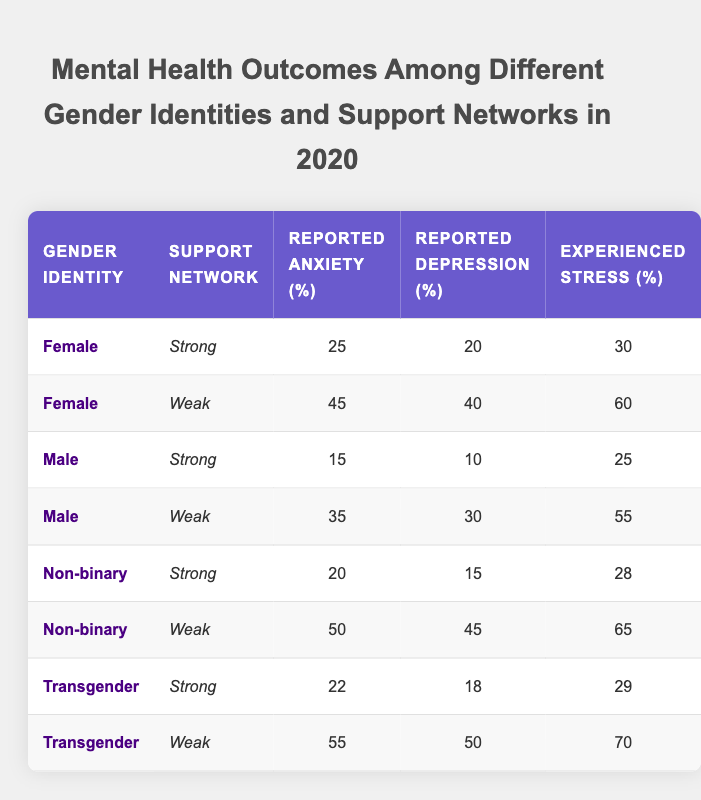What is the reported anxiety percentage for females with a strong support network? According to the table, the reported anxiety percentage for females with a strong support network is 25%. This is found in the first row of the table where the gender identity is Female and the support network is Strong.
Answer: 25% What is the highest reported depression percentage among transgender individuals? The highest reported depression percentage among transgender individuals can be found in the row for those with a weak support network, which shows 50%. We compare this value with the one that has a strong support network (18%) to confirm it as the highest.
Answer: 50% What is the difference in experienced stress between non-binary individuals with weak support and those with strong support? Non-binary individuals with a weak support network have an experienced stress percentage of 65%, while those with a strong support network have a percentage of 28%. The difference is calculated by subtracting 28 from 65, resulting in 37.
Answer: 37 Are males with a weak support network more likely to report anxiety than females with a weak support network? Males with a weak support network report anxiety at 35%, while females with a weak support network report a higher percentage of 45%. Therefore, males are less likely to report anxiety than females in this category.
Answer: No What is the average reported anxiety percentage for all gender identities with a strong support network? To find the average reported anxiety percentage for all gender identities with a strong support network, we identify the values: 25 (Female), 15 (Male), 20 (Non-binary), and 22 (Transgender). We sum these: 25 + 15 + 20 + 22 = 82. There are 4 entries, so we divide by 4: 82/4 = 20.5.
Answer: 20.5 Which group has the highest experienced stress when comparing all weak support networks? Analyzing the weak support network rows, we find: Females (60%), Males (55%), Non-binary (65%), and Transgender (70%). Among these, transgender individuals show the highest experienced stress at 70%.
Answer: Transgender What percentage of non-binary individuals reported anxiety when having a strong support network? Referring to the corresponding row for non-binary individuals with a strong support network, the reported anxiety percentage is found to be 20%.
Answer: 20% How many total cases of reported depression are there across all the entries for males? For males, reported depression percentages are 10 (Strong) and 30 (Weak). The sum of these values is 10 + 30 = 40.
Answer: 40 